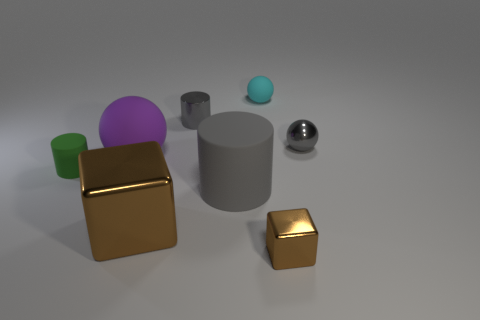Add 2 big matte blocks. How many objects exist? 10 Subtract all cylinders. How many objects are left? 5 Add 7 small cyan metallic blocks. How many small cyan metallic blocks exist? 7 Subtract 0 gray blocks. How many objects are left? 8 Subtract all purple things. Subtract all rubber cylinders. How many objects are left? 5 Add 1 small gray shiny cylinders. How many small gray shiny cylinders are left? 2 